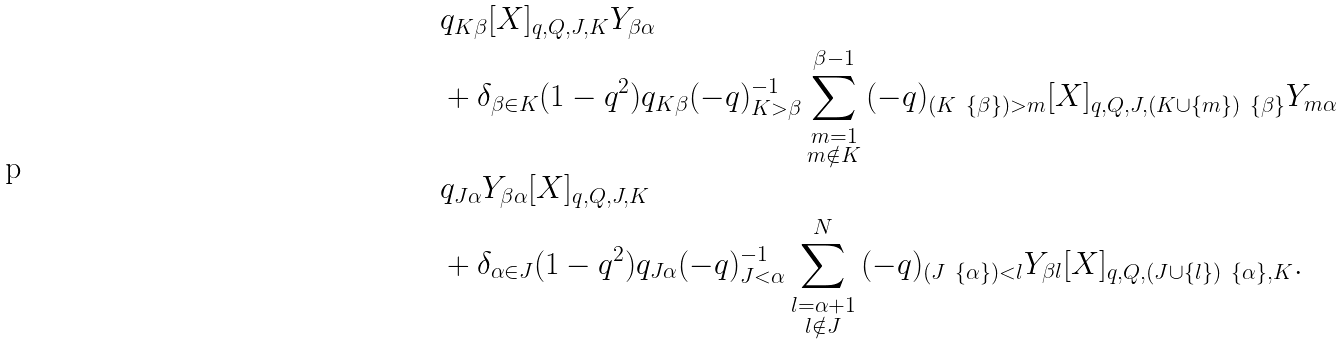<formula> <loc_0><loc_0><loc_500><loc_500>& q _ { K \beta } [ X ] _ { q , Q , J , K } Y _ { \beta \alpha } \\ & + \delta _ { \beta \in K } ( 1 - q ^ { 2 } ) q _ { K \beta } ( - q ) _ { K > \beta } ^ { - 1 } \sum _ { \substack { m = 1 \\ m \notin K } } ^ { \beta - 1 } { ( - q ) _ { ( K \ \{ \beta \} ) > m } [ X ] _ { q , Q , J , ( K \cup \{ m \} ) \ \{ \beta \} } Y _ { m \alpha } } \\ & q _ { J \alpha } Y _ { \beta \alpha } [ X ] _ { q , Q , J , K } \\ & + \delta _ { \alpha \in J } ( 1 - q ^ { 2 } ) q _ { J \alpha } ( - q ) _ { J < \alpha } ^ { - 1 } \sum _ { \substack { l = \alpha + 1 \\ l \notin J } } ^ { N } { ( - q ) _ { ( J \ \{ \alpha \} ) < l } Y _ { \beta l } [ X ] _ { q , Q , ( J \cup \{ l \} ) \ \{ \alpha \} , K } } .</formula> 